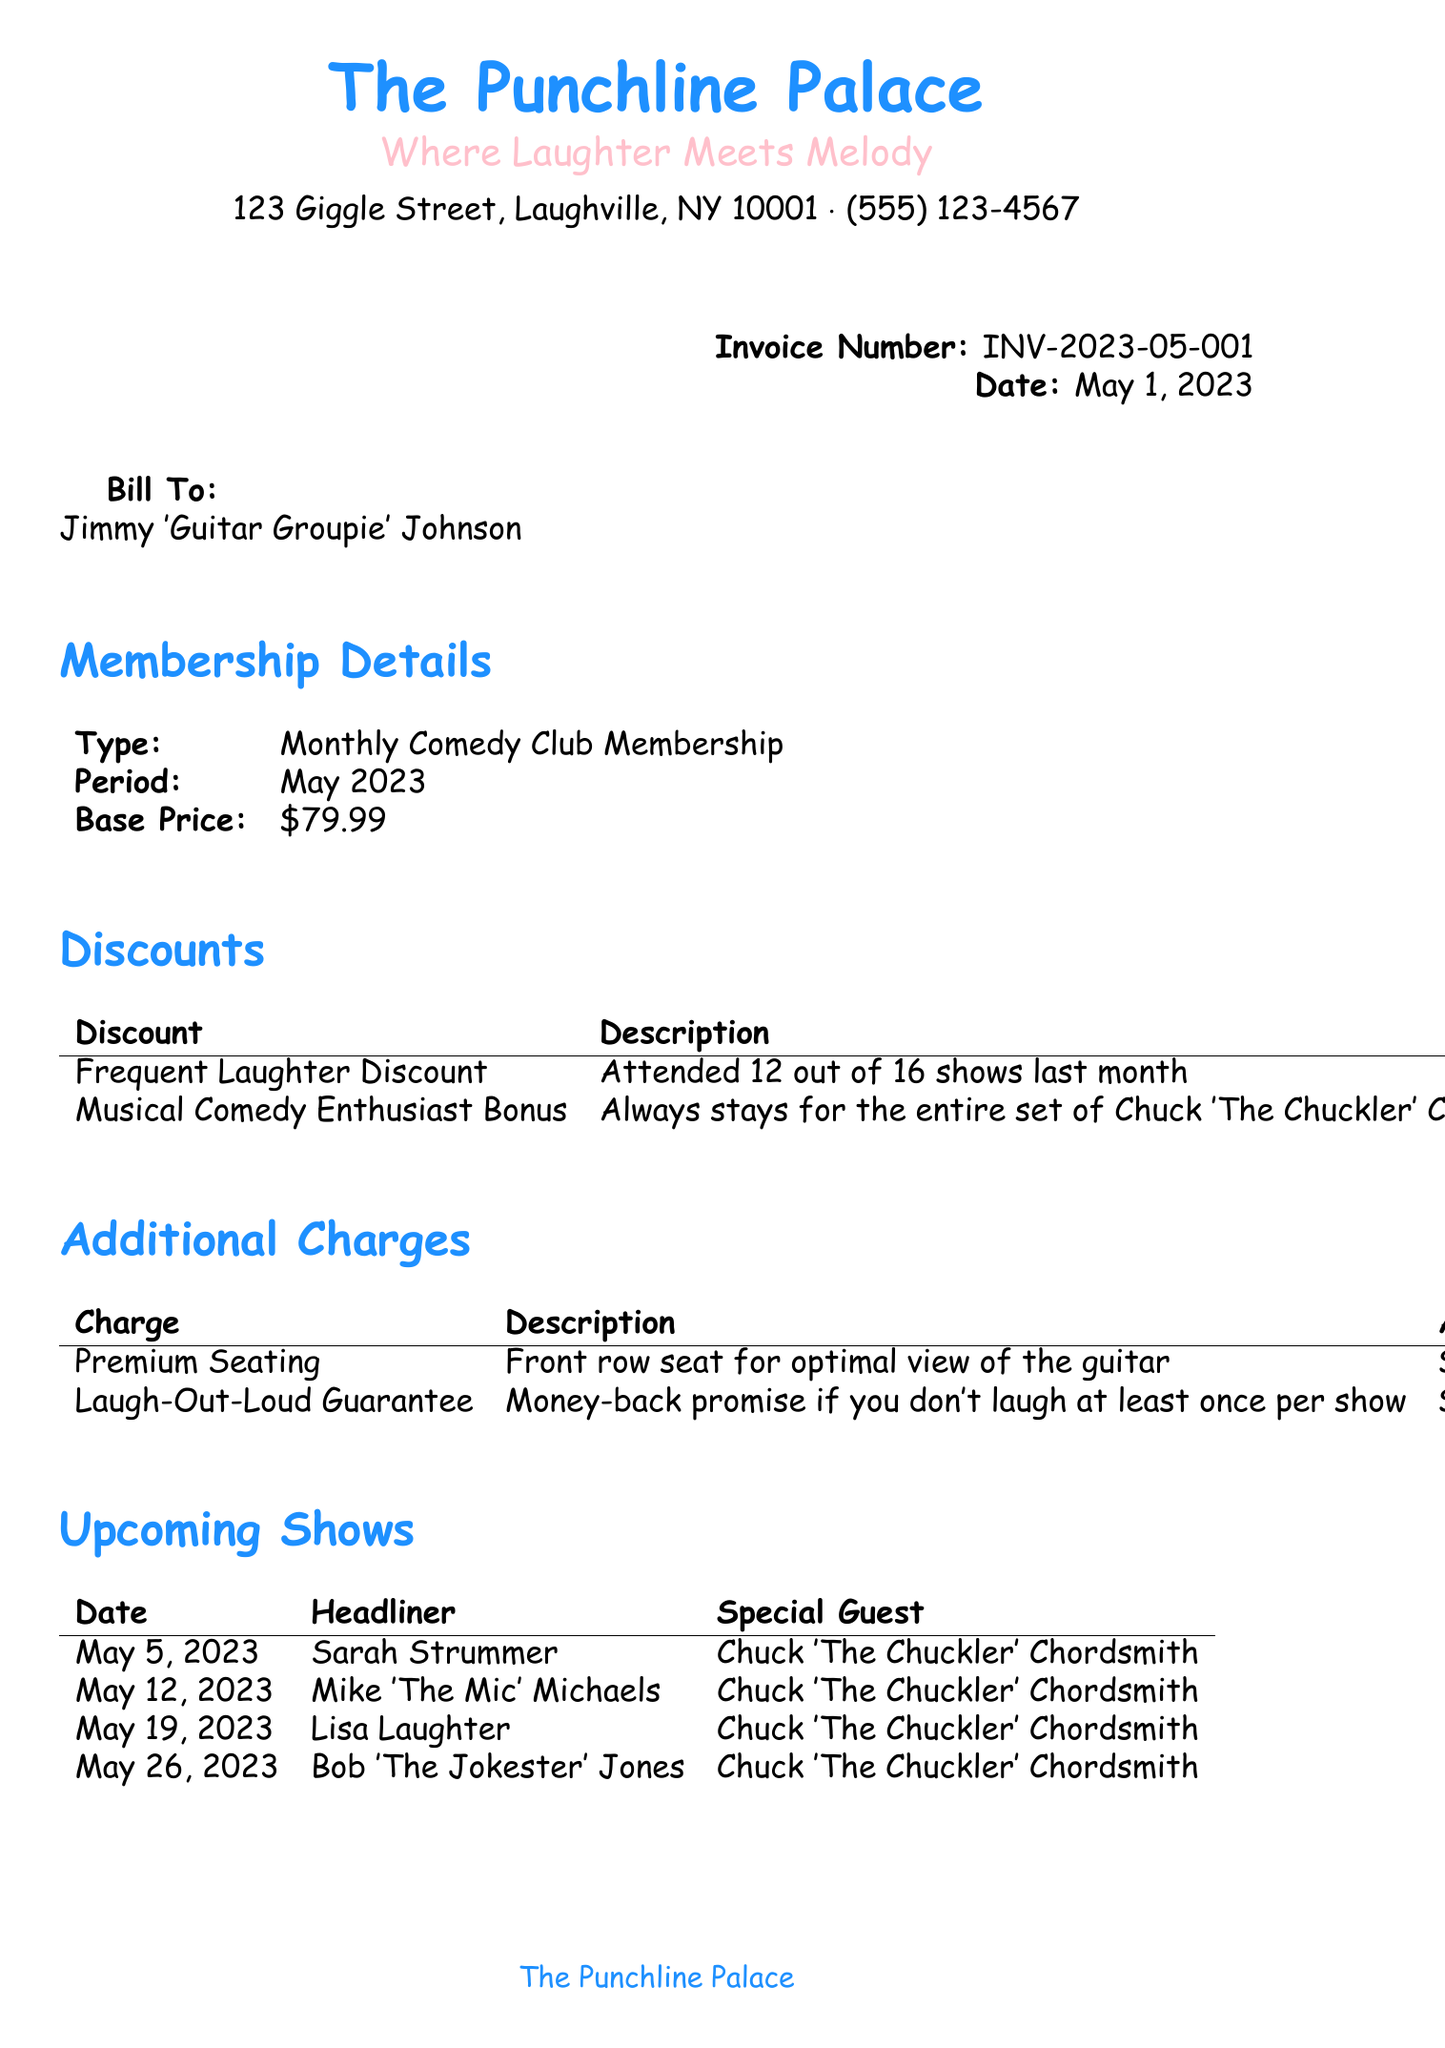What is the invoice number? The invoice number is listed prominently at the top of the document.
Answer: INV-2023-05-001 Who is the customer? The document specifies the customer's name under the billing section.
Answer: Jimmy 'Guitar Groupie' Johnson What is the due date for payment? The due date is indicated in the payment details section.
Answer: May 10, 2023 How much is the 'Frequent Laughter Discount'? The discount amount can be found in the discounts section of the invoice.
Answer: $15.00 What is the base price for the membership type? The base price for the membership is provided in the membership details table.
Answer: $79.99 What total amount is due? The total amount due is mentioned in the payment details section.
Answer: $72.49 How many shows did the customer attend to qualify for the Frequent Laughter Discount? The discount's description provides the specific show attendance information.
Answer: 12 out of 16 shows What additional charge is related to money-back guarantee? The additional charges section lists various charges and their descriptions.
Answer: Laugh-Out-Loud Guarantee Who is the special guest for the upcoming show on May 5, 2023? The upcoming shows section includes details of the headliner and special guest.
Answer: Chuck 'The Chuckler' Chordsmith 